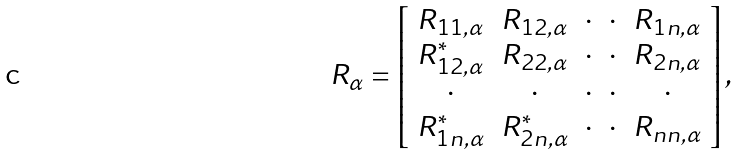Convert formula to latex. <formula><loc_0><loc_0><loc_500><loc_500>R _ { \alpha } = \left [ \begin{array} { c c c c c } R _ { 1 1 , \alpha } & R _ { 1 2 , \alpha } & \cdot & \cdot & R _ { 1 n , \alpha } \\ R _ { 1 2 , \alpha } ^ { * } & R _ { 2 2 , \alpha } & \cdot & \cdot & R _ { 2 n , \alpha } \\ \cdot & \cdot & \cdot & \cdot & \cdot \\ R _ { 1 n , \alpha } ^ { * } & R _ { 2 n , \alpha } ^ { * } & \cdot & \cdot & R _ { n n , \alpha } \\ \end{array} \right ] ,</formula> 